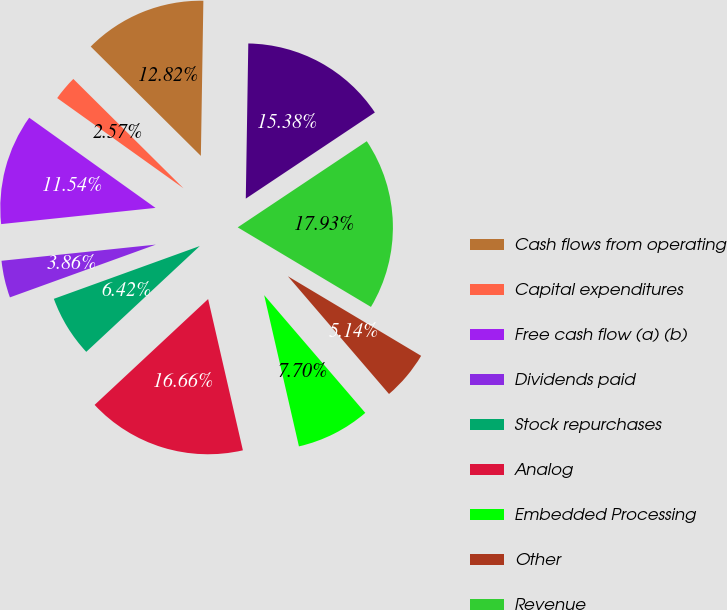<chart> <loc_0><loc_0><loc_500><loc_500><pie_chart><fcel>Cash flows from operating<fcel>Capital expenditures<fcel>Free cash flow (a) (b)<fcel>Dividends paid<fcel>Stock repurchases<fcel>Analog<fcel>Embedded Processing<fcel>Other<fcel>Revenue<fcel>Gross profit<nl><fcel>12.82%<fcel>2.57%<fcel>11.54%<fcel>3.86%<fcel>6.42%<fcel>16.66%<fcel>7.7%<fcel>5.14%<fcel>17.94%<fcel>15.38%<nl></chart> 